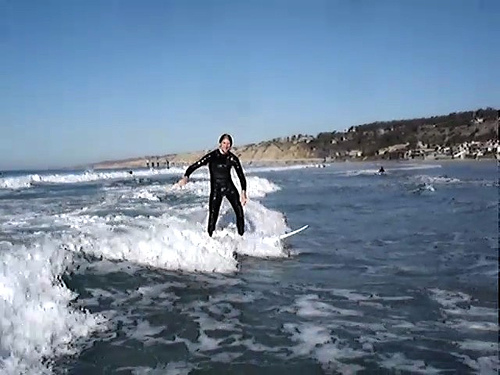<image>Is this man surfing in the Arctic Ocean? I am not sure if the man is surfing in the Arctic Ocean. Is this man surfing in the Arctic Ocean? I don't know if this man is surfing in the Arctic Ocean. It is possible that he is not surfing in the Arctic Ocean, but I am uncertain. 